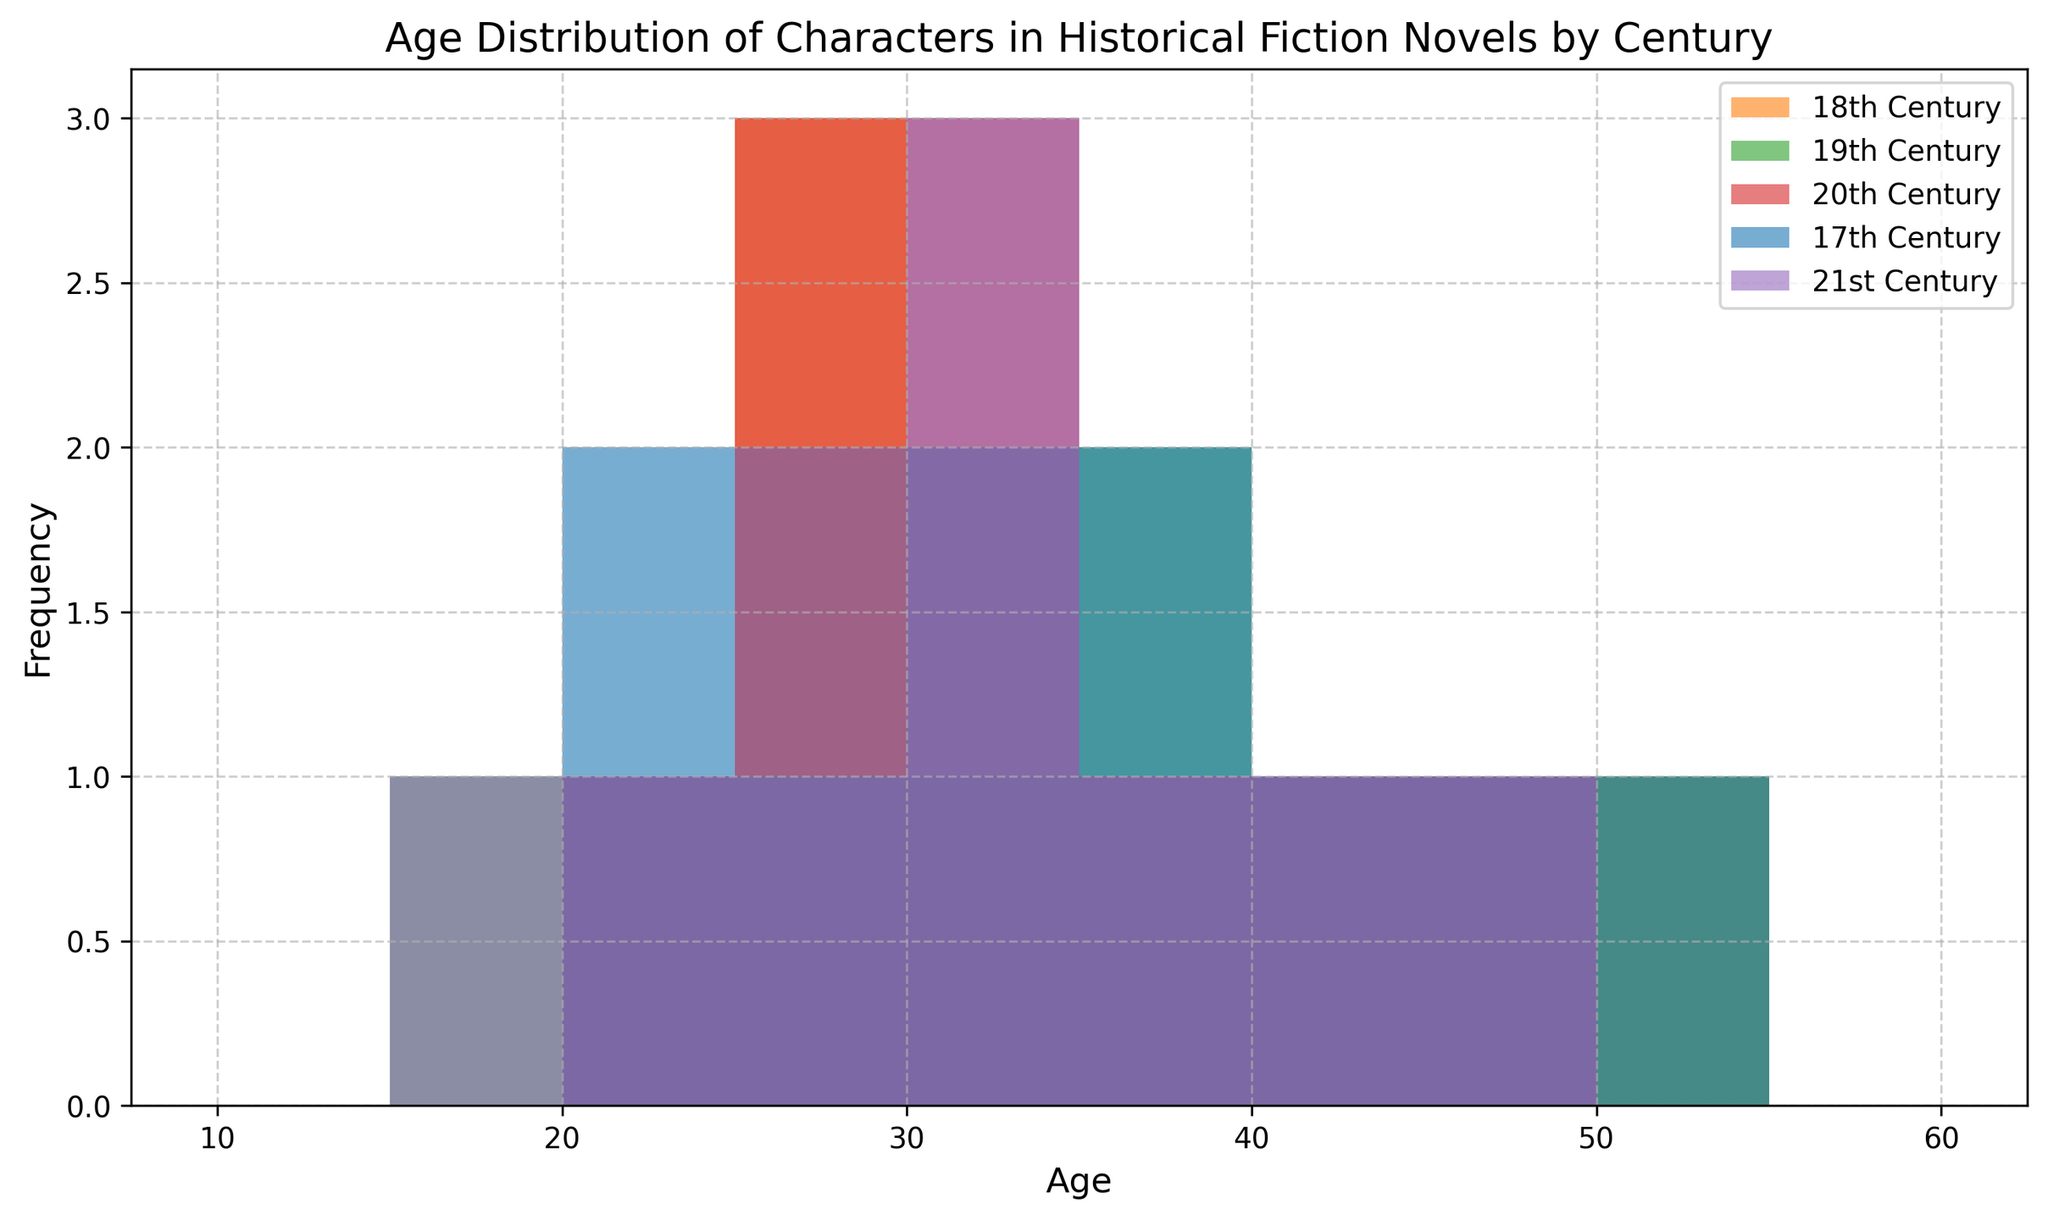Which century has the widest range of character ages? To find the widest range, we look for the greatest difference between the maximum and minimum character ages in each century. Visually, the 17th century has ages ranging from 20 to 50, the 18th century from 22 to 50, the 19th century from 15 to 50, the 20th century from 20 to 45, and the 21st century from 18 to 45.
Answer: 19th Which century has the highest number of characters aged 40 or above? Observing the height of the histogram bars representing characters aged 40 or above, we see that the 17th, 18th, 19th, and 20th centuries each have visually tall bars around ages 40, 45, or 50, but the 19th century has the highest number across these ages.
Answer: 19th How does the frequency of characters aged 20 to 30 in the 20th century compare to that in the 21st century? To compare, observe the bars representing ages 20 to 30. In the 20th century, the bars are relatively higher for ages 20, 25, 28, and 30, while in the 21st century, the bars corresponding to ages 18, 24, 25, 28, and 30 are smaller.
Answer: Higher in the 20th century In which century do characters aged 15-20 appear, and how frequently? We can identify the characters aged 15-20 and their counts by observing the bars for ages 15, 18, and 20. Only the 19th century has bars at age 15 (1 character), and the 21st century has a bar at age 18 (1 character).
Answer: 19th century (1), 21st century (1) What century shows a smaller age distribution for characters aged 30-40 compared to others? We need to check the bars for ages 30 to 40. The 20th and 21st centuries show more consistent frequency in this age range compared to others. The 18th century, particularly, shows fewer characters in this range.
Answer: 18th century Which century has the highest average age for characters? To calculate the average, you need to sum the ages and divide by the number of characters for each century. By visually approximating, the 18th century histogram appears skewed towards higher ages compared to the 20th and 21st centuries. The 19th century has an almost average spread. The 17th century also features many characters around age 40-50. The 17th century likely has the highest mean age.
Answer: 17th century Which century has the most characters aged between 35 and 45? We count the number of bars between ages 35 and 45 for each century. The 17th century shows counts for 35, 40, and 45, the 18th century for 35, 40, and 45, the 19th century for 36, 38, 40, and 45, the 20th century for 37, 40, and 45, and the 21st century for 34, 37, and 45. The highest frequency occurs in the 19th century.
Answer: 19th century Are characters below age 20 more frequent in the 19th century or the 21st century? Characters younger than 20 are shown in bars for ages 15 and 18. The 19th century has a bar at age 15, and the 21st century has a bar at age 18. With only one bar at each, we compare their frequencies, both appear singular.
Answer: Equally frequent What is the most common age of characters in the 18th century? We look for the tallest bar in the 18th-century histogram, indicating the most common age. The bar at age 22 appears highest.
Answer: 22 